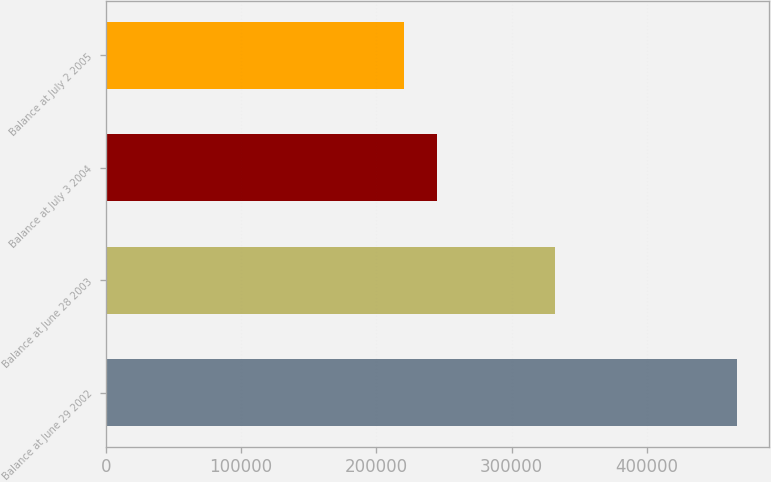<chart> <loc_0><loc_0><loc_500><loc_500><bar_chart><fcel>Balance at June 29 2002<fcel>Balance at June 28 2003<fcel>Balance at July 3 2004<fcel>Balance at July 2 2005<nl><fcel>466719<fcel>332468<fcel>244955<fcel>220315<nl></chart> 